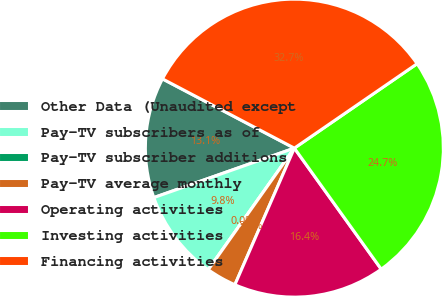Convert chart. <chart><loc_0><loc_0><loc_500><loc_500><pie_chart><fcel>Other Data (Unaudited except<fcel>Pay-TV subscribers as of<fcel>Pay-TV subscriber additions<fcel>Pay-TV average monthly<fcel>Operating activities<fcel>Investing activities<fcel>Financing activities<nl><fcel>13.08%<fcel>9.81%<fcel>0.0%<fcel>3.27%<fcel>16.44%<fcel>24.68%<fcel>32.71%<nl></chart> 